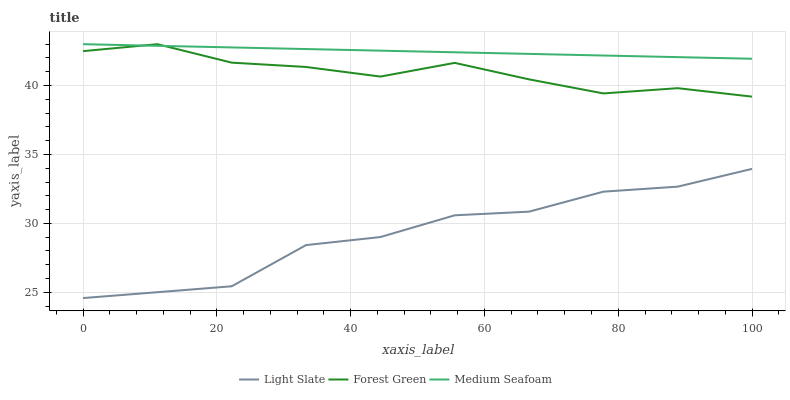Does Light Slate have the minimum area under the curve?
Answer yes or no. Yes. Does Medium Seafoam have the maximum area under the curve?
Answer yes or no. Yes. Does Forest Green have the minimum area under the curve?
Answer yes or no. No. Does Forest Green have the maximum area under the curve?
Answer yes or no. No. Is Medium Seafoam the smoothest?
Answer yes or no. Yes. Is Light Slate the roughest?
Answer yes or no. Yes. Is Forest Green the smoothest?
Answer yes or no. No. Is Forest Green the roughest?
Answer yes or no. No. Does Light Slate have the lowest value?
Answer yes or no. Yes. Does Forest Green have the lowest value?
Answer yes or no. No. Does Medium Seafoam have the highest value?
Answer yes or no. Yes. Is Light Slate less than Medium Seafoam?
Answer yes or no. Yes. Is Forest Green greater than Light Slate?
Answer yes or no. Yes. Does Medium Seafoam intersect Forest Green?
Answer yes or no. Yes. Is Medium Seafoam less than Forest Green?
Answer yes or no. No. Is Medium Seafoam greater than Forest Green?
Answer yes or no. No. Does Light Slate intersect Medium Seafoam?
Answer yes or no. No. 